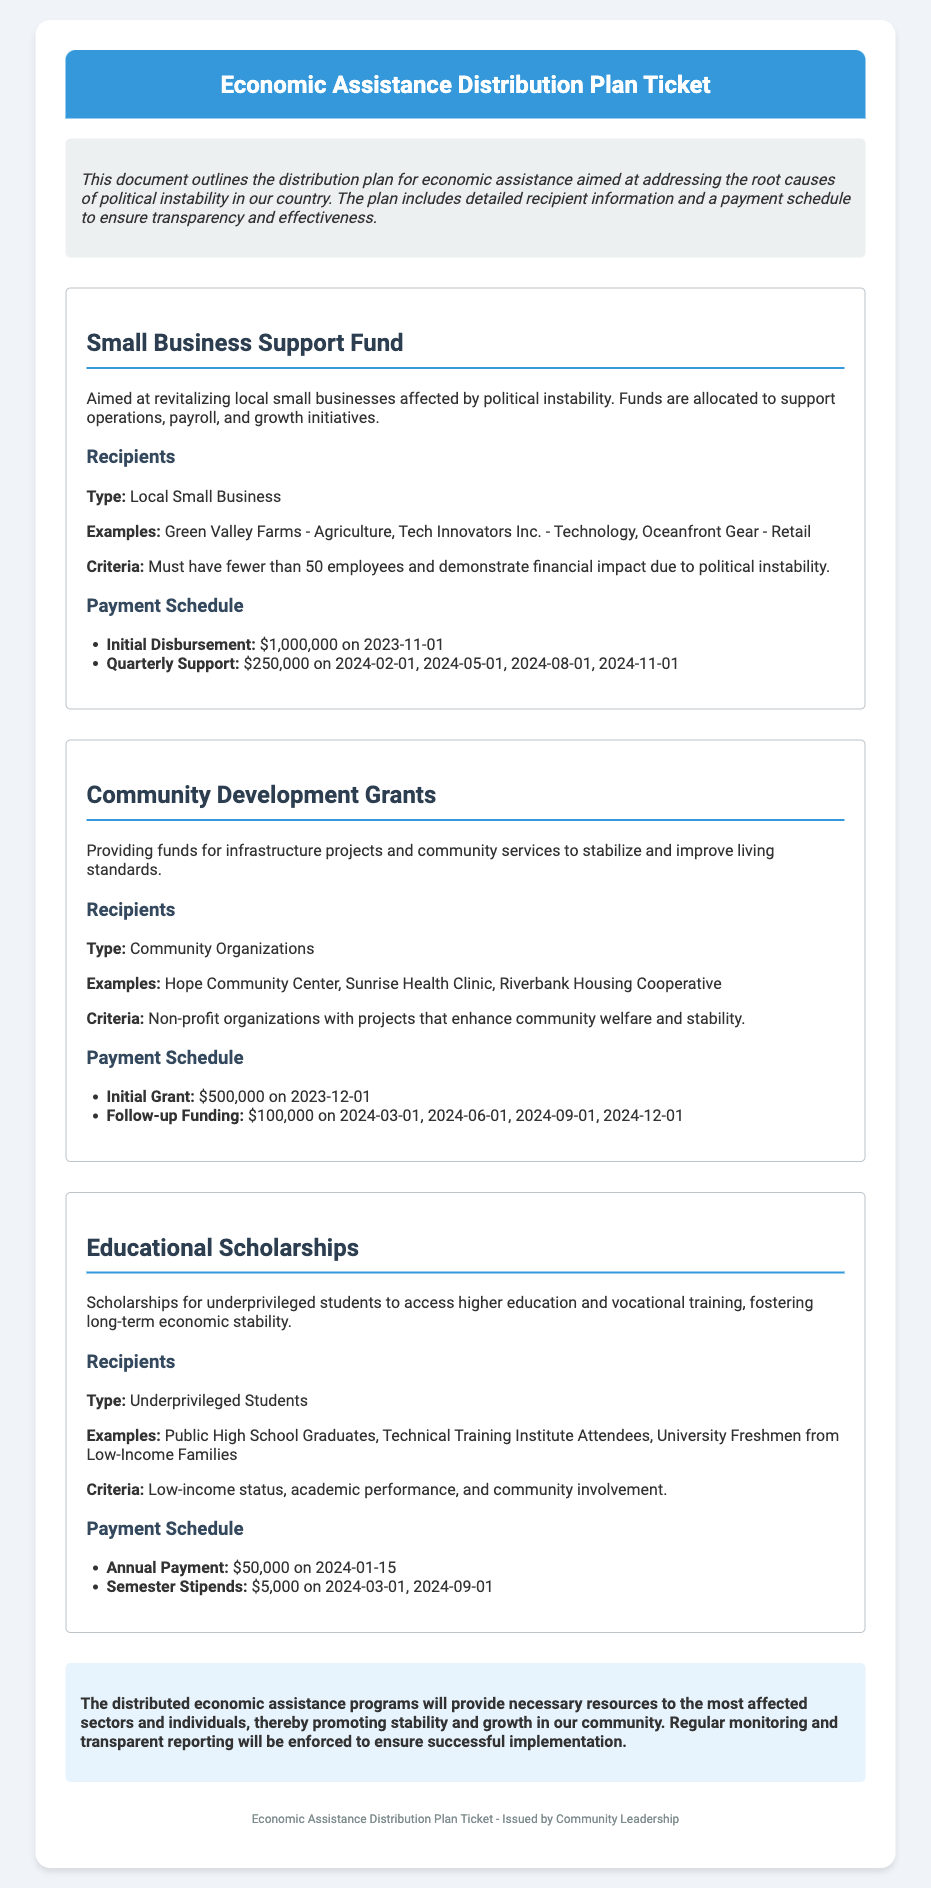What is the title of the document? The title of the document is mentioned in the header section of the ticket.
Answer: Economic Assistance Distribution Plan Ticket What is the total amount allocated for the Small Business Support Fund initial disbursement? This amount can be found in the payment schedule for the Small Business Support Fund.
Answer: $1,000,000 Which organization is an example recipient for Community Development Grants? The examples of recipients are listed under the recipients section for the Community Development Grants program.
Answer: Hope Community Center When is the first payment for the Educational Scholarships scheduled? The payment schedule for Educational Scholarships details when the first payment is to occur.
Answer: 2024-01-15 What type of organizations qualify for the Community Development Grants? The criteria for recipients is specified in the recipients section of the Community Development Grants program.
Answer: Community Organizations What is the criteria for recipients of the Small Business Support Fund? The criteria for eligibility is described in the recipients section of the Small Business Support Fund.
Answer: Must have fewer than 50 employees and demonstrate financial impact due to political instability How often are the quarterly payments for the Small Business Support Fund? The payment schedule indicates the frequency of the payments for the Small Business Support Fund.
Answer: Quarterly What is the purpose of the Educational Scholarships program? The objective of the Educational Scholarships program is stated in the description section of the program.
Answer: Fostering long-term economic stability How much is the follow-up funding for Community Development Grants? This figure is provided in the payment schedule for Community Development Grants.
Answer: $100,000 What will be enforced for successful implementation of the economic assistance programs? The conclusion section discusses what measures will be in place for these programs.
Answer: Regular monitoring and transparent reporting 